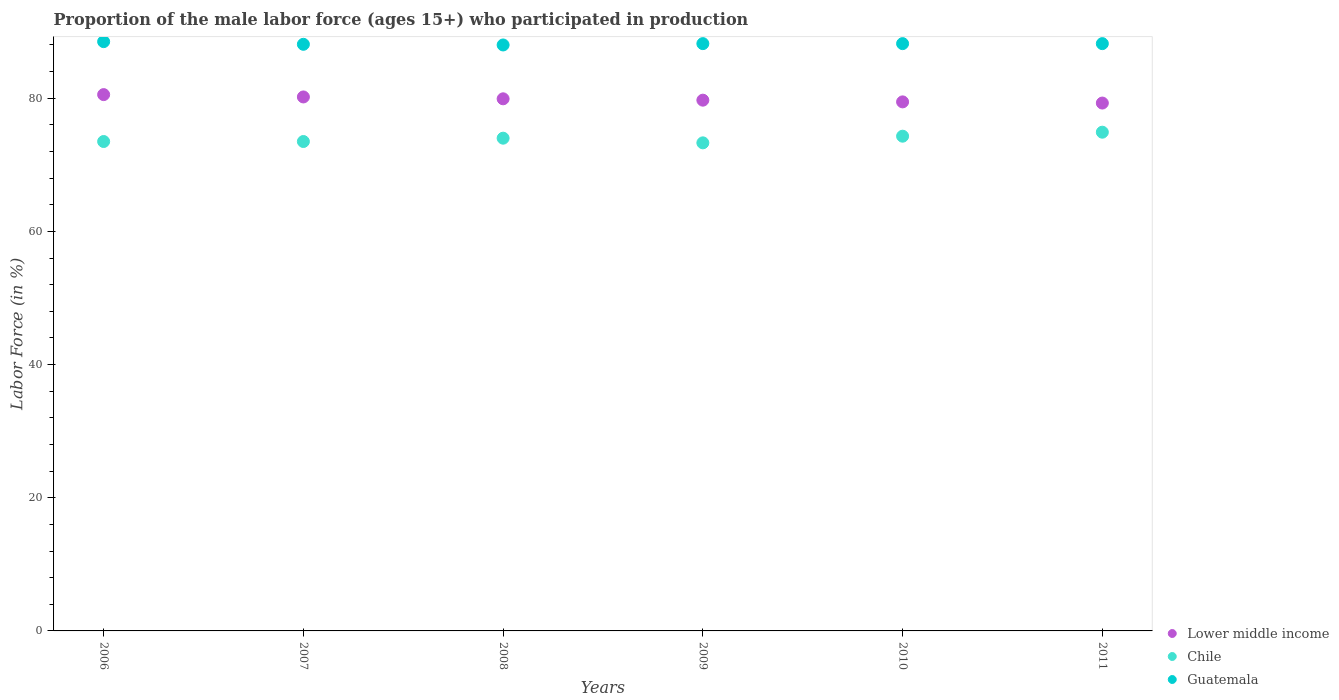How many different coloured dotlines are there?
Provide a short and direct response. 3. Is the number of dotlines equal to the number of legend labels?
Offer a very short reply. Yes. What is the proportion of the male labor force who participated in production in Guatemala in 2010?
Ensure brevity in your answer.  88.2. Across all years, what is the maximum proportion of the male labor force who participated in production in Guatemala?
Make the answer very short. 88.5. Across all years, what is the minimum proportion of the male labor force who participated in production in Chile?
Offer a very short reply. 73.3. In which year was the proportion of the male labor force who participated in production in Guatemala minimum?
Give a very brief answer. 2008. What is the total proportion of the male labor force who participated in production in Lower middle income in the graph?
Keep it short and to the point. 479.09. What is the difference between the proportion of the male labor force who participated in production in Lower middle income in 2007 and that in 2009?
Ensure brevity in your answer.  0.48. What is the difference between the proportion of the male labor force who participated in production in Guatemala in 2007 and the proportion of the male labor force who participated in production in Lower middle income in 2010?
Offer a terse response. 8.65. What is the average proportion of the male labor force who participated in production in Lower middle income per year?
Offer a very short reply. 79.85. In the year 2011, what is the difference between the proportion of the male labor force who participated in production in Chile and proportion of the male labor force who participated in production in Guatemala?
Provide a succinct answer. -13.3. In how many years, is the proportion of the male labor force who participated in production in Guatemala greater than 64 %?
Provide a short and direct response. 6. What is the ratio of the proportion of the male labor force who participated in production in Guatemala in 2007 to that in 2009?
Your answer should be compact. 1. Is the difference between the proportion of the male labor force who participated in production in Chile in 2009 and 2010 greater than the difference between the proportion of the male labor force who participated in production in Guatemala in 2009 and 2010?
Your answer should be compact. No. What is the difference between the highest and the second highest proportion of the male labor force who participated in production in Chile?
Provide a short and direct response. 0.6. What is the difference between the highest and the lowest proportion of the male labor force who participated in production in Lower middle income?
Your answer should be very brief. 1.27. In how many years, is the proportion of the male labor force who participated in production in Lower middle income greater than the average proportion of the male labor force who participated in production in Lower middle income taken over all years?
Ensure brevity in your answer.  3. Does the proportion of the male labor force who participated in production in Guatemala monotonically increase over the years?
Offer a very short reply. No. Is the proportion of the male labor force who participated in production in Lower middle income strictly greater than the proportion of the male labor force who participated in production in Guatemala over the years?
Make the answer very short. No. How many dotlines are there?
Provide a succinct answer. 3. Does the graph contain any zero values?
Provide a short and direct response. No. Does the graph contain grids?
Provide a succinct answer. No. How are the legend labels stacked?
Your answer should be compact. Vertical. What is the title of the graph?
Your response must be concise. Proportion of the male labor force (ages 15+) who participated in production. What is the label or title of the X-axis?
Give a very brief answer. Years. What is the Labor Force (in %) of Lower middle income in 2006?
Offer a terse response. 80.54. What is the Labor Force (in %) of Chile in 2006?
Your answer should be very brief. 73.5. What is the Labor Force (in %) in Guatemala in 2006?
Keep it short and to the point. 88.5. What is the Labor Force (in %) in Lower middle income in 2007?
Offer a very short reply. 80.19. What is the Labor Force (in %) in Chile in 2007?
Give a very brief answer. 73.5. What is the Labor Force (in %) in Guatemala in 2007?
Offer a very short reply. 88.1. What is the Labor Force (in %) in Lower middle income in 2008?
Offer a very short reply. 79.91. What is the Labor Force (in %) of Chile in 2008?
Provide a short and direct response. 74. What is the Labor Force (in %) of Lower middle income in 2009?
Offer a very short reply. 79.71. What is the Labor Force (in %) of Chile in 2009?
Provide a short and direct response. 73.3. What is the Labor Force (in %) of Guatemala in 2009?
Your answer should be very brief. 88.2. What is the Labor Force (in %) in Lower middle income in 2010?
Your response must be concise. 79.45. What is the Labor Force (in %) in Chile in 2010?
Your response must be concise. 74.3. What is the Labor Force (in %) in Guatemala in 2010?
Offer a terse response. 88.2. What is the Labor Force (in %) of Lower middle income in 2011?
Provide a succinct answer. 79.28. What is the Labor Force (in %) in Chile in 2011?
Keep it short and to the point. 74.9. What is the Labor Force (in %) of Guatemala in 2011?
Give a very brief answer. 88.2. Across all years, what is the maximum Labor Force (in %) of Lower middle income?
Ensure brevity in your answer.  80.54. Across all years, what is the maximum Labor Force (in %) of Chile?
Provide a succinct answer. 74.9. Across all years, what is the maximum Labor Force (in %) in Guatemala?
Keep it short and to the point. 88.5. Across all years, what is the minimum Labor Force (in %) in Lower middle income?
Your answer should be very brief. 79.28. Across all years, what is the minimum Labor Force (in %) in Chile?
Give a very brief answer. 73.3. Across all years, what is the minimum Labor Force (in %) in Guatemala?
Offer a terse response. 88. What is the total Labor Force (in %) of Lower middle income in the graph?
Provide a short and direct response. 479.09. What is the total Labor Force (in %) in Chile in the graph?
Ensure brevity in your answer.  443.5. What is the total Labor Force (in %) in Guatemala in the graph?
Your answer should be very brief. 529.2. What is the difference between the Labor Force (in %) in Lower middle income in 2006 and that in 2007?
Your answer should be very brief. 0.35. What is the difference between the Labor Force (in %) in Guatemala in 2006 and that in 2007?
Offer a terse response. 0.4. What is the difference between the Labor Force (in %) in Lower middle income in 2006 and that in 2008?
Provide a short and direct response. 0.63. What is the difference between the Labor Force (in %) of Guatemala in 2006 and that in 2008?
Keep it short and to the point. 0.5. What is the difference between the Labor Force (in %) of Lower middle income in 2006 and that in 2009?
Ensure brevity in your answer.  0.83. What is the difference between the Labor Force (in %) of Lower middle income in 2006 and that in 2010?
Give a very brief answer. 1.09. What is the difference between the Labor Force (in %) of Chile in 2006 and that in 2010?
Make the answer very short. -0.8. What is the difference between the Labor Force (in %) of Guatemala in 2006 and that in 2010?
Provide a succinct answer. 0.3. What is the difference between the Labor Force (in %) in Lower middle income in 2006 and that in 2011?
Your response must be concise. 1.27. What is the difference between the Labor Force (in %) of Lower middle income in 2007 and that in 2008?
Make the answer very short. 0.28. What is the difference between the Labor Force (in %) in Chile in 2007 and that in 2008?
Your answer should be compact. -0.5. What is the difference between the Labor Force (in %) of Lower middle income in 2007 and that in 2009?
Offer a very short reply. 0.48. What is the difference between the Labor Force (in %) in Chile in 2007 and that in 2009?
Your answer should be compact. 0.2. What is the difference between the Labor Force (in %) in Guatemala in 2007 and that in 2009?
Your answer should be very brief. -0.1. What is the difference between the Labor Force (in %) of Lower middle income in 2007 and that in 2010?
Provide a short and direct response. 0.74. What is the difference between the Labor Force (in %) in Guatemala in 2007 and that in 2010?
Keep it short and to the point. -0.1. What is the difference between the Labor Force (in %) in Lower middle income in 2007 and that in 2011?
Your answer should be compact. 0.92. What is the difference between the Labor Force (in %) of Chile in 2007 and that in 2011?
Make the answer very short. -1.4. What is the difference between the Labor Force (in %) in Guatemala in 2007 and that in 2011?
Offer a terse response. -0.1. What is the difference between the Labor Force (in %) of Lower middle income in 2008 and that in 2009?
Ensure brevity in your answer.  0.2. What is the difference between the Labor Force (in %) in Chile in 2008 and that in 2009?
Your answer should be very brief. 0.7. What is the difference between the Labor Force (in %) of Guatemala in 2008 and that in 2009?
Your response must be concise. -0.2. What is the difference between the Labor Force (in %) of Lower middle income in 2008 and that in 2010?
Offer a terse response. 0.46. What is the difference between the Labor Force (in %) in Lower middle income in 2008 and that in 2011?
Your answer should be very brief. 0.64. What is the difference between the Labor Force (in %) of Chile in 2008 and that in 2011?
Provide a succinct answer. -0.9. What is the difference between the Labor Force (in %) of Guatemala in 2008 and that in 2011?
Your response must be concise. -0.2. What is the difference between the Labor Force (in %) of Lower middle income in 2009 and that in 2010?
Make the answer very short. 0.26. What is the difference between the Labor Force (in %) of Guatemala in 2009 and that in 2010?
Provide a short and direct response. 0. What is the difference between the Labor Force (in %) of Lower middle income in 2009 and that in 2011?
Offer a terse response. 0.43. What is the difference between the Labor Force (in %) of Guatemala in 2009 and that in 2011?
Offer a very short reply. 0. What is the difference between the Labor Force (in %) in Lower middle income in 2010 and that in 2011?
Make the answer very short. 0.18. What is the difference between the Labor Force (in %) of Guatemala in 2010 and that in 2011?
Make the answer very short. 0. What is the difference between the Labor Force (in %) in Lower middle income in 2006 and the Labor Force (in %) in Chile in 2007?
Offer a very short reply. 7.04. What is the difference between the Labor Force (in %) in Lower middle income in 2006 and the Labor Force (in %) in Guatemala in 2007?
Your response must be concise. -7.56. What is the difference between the Labor Force (in %) of Chile in 2006 and the Labor Force (in %) of Guatemala in 2007?
Give a very brief answer. -14.6. What is the difference between the Labor Force (in %) in Lower middle income in 2006 and the Labor Force (in %) in Chile in 2008?
Your answer should be very brief. 6.54. What is the difference between the Labor Force (in %) in Lower middle income in 2006 and the Labor Force (in %) in Guatemala in 2008?
Your response must be concise. -7.46. What is the difference between the Labor Force (in %) of Lower middle income in 2006 and the Labor Force (in %) of Chile in 2009?
Ensure brevity in your answer.  7.24. What is the difference between the Labor Force (in %) of Lower middle income in 2006 and the Labor Force (in %) of Guatemala in 2009?
Provide a short and direct response. -7.66. What is the difference between the Labor Force (in %) in Chile in 2006 and the Labor Force (in %) in Guatemala in 2009?
Offer a very short reply. -14.7. What is the difference between the Labor Force (in %) in Lower middle income in 2006 and the Labor Force (in %) in Chile in 2010?
Make the answer very short. 6.24. What is the difference between the Labor Force (in %) of Lower middle income in 2006 and the Labor Force (in %) of Guatemala in 2010?
Your answer should be compact. -7.66. What is the difference between the Labor Force (in %) of Chile in 2006 and the Labor Force (in %) of Guatemala in 2010?
Offer a very short reply. -14.7. What is the difference between the Labor Force (in %) of Lower middle income in 2006 and the Labor Force (in %) of Chile in 2011?
Ensure brevity in your answer.  5.64. What is the difference between the Labor Force (in %) in Lower middle income in 2006 and the Labor Force (in %) in Guatemala in 2011?
Give a very brief answer. -7.66. What is the difference between the Labor Force (in %) in Chile in 2006 and the Labor Force (in %) in Guatemala in 2011?
Make the answer very short. -14.7. What is the difference between the Labor Force (in %) of Lower middle income in 2007 and the Labor Force (in %) of Chile in 2008?
Keep it short and to the point. 6.19. What is the difference between the Labor Force (in %) in Lower middle income in 2007 and the Labor Force (in %) in Guatemala in 2008?
Provide a short and direct response. -7.81. What is the difference between the Labor Force (in %) in Chile in 2007 and the Labor Force (in %) in Guatemala in 2008?
Your answer should be compact. -14.5. What is the difference between the Labor Force (in %) in Lower middle income in 2007 and the Labor Force (in %) in Chile in 2009?
Make the answer very short. 6.89. What is the difference between the Labor Force (in %) in Lower middle income in 2007 and the Labor Force (in %) in Guatemala in 2009?
Your response must be concise. -8.01. What is the difference between the Labor Force (in %) in Chile in 2007 and the Labor Force (in %) in Guatemala in 2009?
Provide a short and direct response. -14.7. What is the difference between the Labor Force (in %) in Lower middle income in 2007 and the Labor Force (in %) in Chile in 2010?
Offer a very short reply. 5.89. What is the difference between the Labor Force (in %) of Lower middle income in 2007 and the Labor Force (in %) of Guatemala in 2010?
Provide a short and direct response. -8.01. What is the difference between the Labor Force (in %) in Chile in 2007 and the Labor Force (in %) in Guatemala in 2010?
Your answer should be very brief. -14.7. What is the difference between the Labor Force (in %) in Lower middle income in 2007 and the Labor Force (in %) in Chile in 2011?
Make the answer very short. 5.29. What is the difference between the Labor Force (in %) in Lower middle income in 2007 and the Labor Force (in %) in Guatemala in 2011?
Give a very brief answer. -8.01. What is the difference between the Labor Force (in %) in Chile in 2007 and the Labor Force (in %) in Guatemala in 2011?
Your response must be concise. -14.7. What is the difference between the Labor Force (in %) in Lower middle income in 2008 and the Labor Force (in %) in Chile in 2009?
Give a very brief answer. 6.61. What is the difference between the Labor Force (in %) of Lower middle income in 2008 and the Labor Force (in %) of Guatemala in 2009?
Give a very brief answer. -8.29. What is the difference between the Labor Force (in %) in Lower middle income in 2008 and the Labor Force (in %) in Chile in 2010?
Your response must be concise. 5.61. What is the difference between the Labor Force (in %) in Lower middle income in 2008 and the Labor Force (in %) in Guatemala in 2010?
Provide a succinct answer. -8.29. What is the difference between the Labor Force (in %) in Lower middle income in 2008 and the Labor Force (in %) in Chile in 2011?
Your answer should be compact. 5.01. What is the difference between the Labor Force (in %) in Lower middle income in 2008 and the Labor Force (in %) in Guatemala in 2011?
Your response must be concise. -8.29. What is the difference between the Labor Force (in %) in Lower middle income in 2009 and the Labor Force (in %) in Chile in 2010?
Ensure brevity in your answer.  5.41. What is the difference between the Labor Force (in %) of Lower middle income in 2009 and the Labor Force (in %) of Guatemala in 2010?
Give a very brief answer. -8.49. What is the difference between the Labor Force (in %) in Chile in 2009 and the Labor Force (in %) in Guatemala in 2010?
Provide a succinct answer. -14.9. What is the difference between the Labor Force (in %) in Lower middle income in 2009 and the Labor Force (in %) in Chile in 2011?
Give a very brief answer. 4.81. What is the difference between the Labor Force (in %) in Lower middle income in 2009 and the Labor Force (in %) in Guatemala in 2011?
Make the answer very short. -8.49. What is the difference between the Labor Force (in %) in Chile in 2009 and the Labor Force (in %) in Guatemala in 2011?
Your response must be concise. -14.9. What is the difference between the Labor Force (in %) in Lower middle income in 2010 and the Labor Force (in %) in Chile in 2011?
Your response must be concise. 4.55. What is the difference between the Labor Force (in %) in Lower middle income in 2010 and the Labor Force (in %) in Guatemala in 2011?
Your answer should be very brief. -8.75. What is the average Labor Force (in %) of Lower middle income per year?
Your response must be concise. 79.85. What is the average Labor Force (in %) of Chile per year?
Offer a very short reply. 73.92. What is the average Labor Force (in %) in Guatemala per year?
Your response must be concise. 88.2. In the year 2006, what is the difference between the Labor Force (in %) of Lower middle income and Labor Force (in %) of Chile?
Give a very brief answer. 7.04. In the year 2006, what is the difference between the Labor Force (in %) of Lower middle income and Labor Force (in %) of Guatemala?
Offer a terse response. -7.96. In the year 2006, what is the difference between the Labor Force (in %) of Chile and Labor Force (in %) of Guatemala?
Your answer should be very brief. -15. In the year 2007, what is the difference between the Labor Force (in %) of Lower middle income and Labor Force (in %) of Chile?
Ensure brevity in your answer.  6.69. In the year 2007, what is the difference between the Labor Force (in %) in Lower middle income and Labor Force (in %) in Guatemala?
Provide a succinct answer. -7.91. In the year 2007, what is the difference between the Labor Force (in %) in Chile and Labor Force (in %) in Guatemala?
Offer a very short reply. -14.6. In the year 2008, what is the difference between the Labor Force (in %) of Lower middle income and Labor Force (in %) of Chile?
Keep it short and to the point. 5.91. In the year 2008, what is the difference between the Labor Force (in %) of Lower middle income and Labor Force (in %) of Guatemala?
Offer a terse response. -8.09. In the year 2009, what is the difference between the Labor Force (in %) of Lower middle income and Labor Force (in %) of Chile?
Offer a very short reply. 6.41. In the year 2009, what is the difference between the Labor Force (in %) of Lower middle income and Labor Force (in %) of Guatemala?
Give a very brief answer. -8.49. In the year 2009, what is the difference between the Labor Force (in %) in Chile and Labor Force (in %) in Guatemala?
Offer a terse response. -14.9. In the year 2010, what is the difference between the Labor Force (in %) in Lower middle income and Labor Force (in %) in Chile?
Keep it short and to the point. 5.15. In the year 2010, what is the difference between the Labor Force (in %) in Lower middle income and Labor Force (in %) in Guatemala?
Provide a succinct answer. -8.75. In the year 2011, what is the difference between the Labor Force (in %) of Lower middle income and Labor Force (in %) of Chile?
Provide a succinct answer. 4.38. In the year 2011, what is the difference between the Labor Force (in %) in Lower middle income and Labor Force (in %) in Guatemala?
Provide a short and direct response. -8.92. What is the ratio of the Labor Force (in %) of Chile in 2006 to that in 2007?
Provide a short and direct response. 1. What is the ratio of the Labor Force (in %) in Lower middle income in 2006 to that in 2008?
Your answer should be compact. 1.01. What is the ratio of the Labor Force (in %) in Guatemala in 2006 to that in 2008?
Your answer should be compact. 1.01. What is the ratio of the Labor Force (in %) of Lower middle income in 2006 to that in 2009?
Keep it short and to the point. 1.01. What is the ratio of the Labor Force (in %) in Guatemala in 2006 to that in 2009?
Provide a succinct answer. 1. What is the ratio of the Labor Force (in %) in Lower middle income in 2006 to that in 2010?
Offer a very short reply. 1.01. What is the ratio of the Labor Force (in %) in Chile in 2006 to that in 2010?
Provide a succinct answer. 0.99. What is the ratio of the Labor Force (in %) of Lower middle income in 2006 to that in 2011?
Offer a very short reply. 1.02. What is the ratio of the Labor Force (in %) in Chile in 2006 to that in 2011?
Your answer should be very brief. 0.98. What is the ratio of the Labor Force (in %) in Guatemala in 2006 to that in 2011?
Provide a succinct answer. 1. What is the ratio of the Labor Force (in %) of Lower middle income in 2007 to that in 2008?
Your answer should be compact. 1. What is the ratio of the Labor Force (in %) in Guatemala in 2007 to that in 2008?
Provide a short and direct response. 1. What is the ratio of the Labor Force (in %) in Lower middle income in 2007 to that in 2010?
Offer a very short reply. 1.01. What is the ratio of the Labor Force (in %) in Lower middle income in 2007 to that in 2011?
Your answer should be compact. 1.01. What is the ratio of the Labor Force (in %) of Chile in 2007 to that in 2011?
Give a very brief answer. 0.98. What is the ratio of the Labor Force (in %) in Guatemala in 2007 to that in 2011?
Give a very brief answer. 1. What is the ratio of the Labor Force (in %) in Chile in 2008 to that in 2009?
Provide a succinct answer. 1.01. What is the ratio of the Labor Force (in %) of Chile in 2008 to that in 2010?
Your answer should be very brief. 1. What is the ratio of the Labor Force (in %) of Lower middle income in 2008 to that in 2011?
Provide a short and direct response. 1.01. What is the ratio of the Labor Force (in %) in Chile in 2008 to that in 2011?
Your response must be concise. 0.99. What is the ratio of the Labor Force (in %) of Guatemala in 2008 to that in 2011?
Your response must be concise. 1. What is the ratio of the Labor Force (in %) of Chile in 2009 to that in 2010?
Your answer should be very brief. 0.99. What is the ratio of the Labor Force (in %) in Lower middle income in 2009 to that in 2011?
Make the answer very short. 1.01. What is the ratio of the Labor Force (in %) of Chile in 2009 to that in 2011?
Your answer should be compact. 0.98. What is the ratio of the Labor Force (in %) of Guatemala in 2009 to that in 2011?
Your answer should be very brief. 1. What is the difference between the highest and the second highest Labor Force (in %) of Lower middle income?
Make the answer very short. 0.35. What is the difference between the highest and the second highest Labor Force (in %) in Chile?
Your answer should be compact. 0.6. What is the difference between the highest and the lowest Labor Force (in %) in Lower middle income?
Provide a short and direct response. 1.27. What is the difference between the highest and the lowest Labor Force (in %) in Chile?
Ensure brevity in your answer.  1.6. What is the difference between the highest and the lowest Labor Force (in %) of Guatemala?
Your response must be concise. 0.5. 